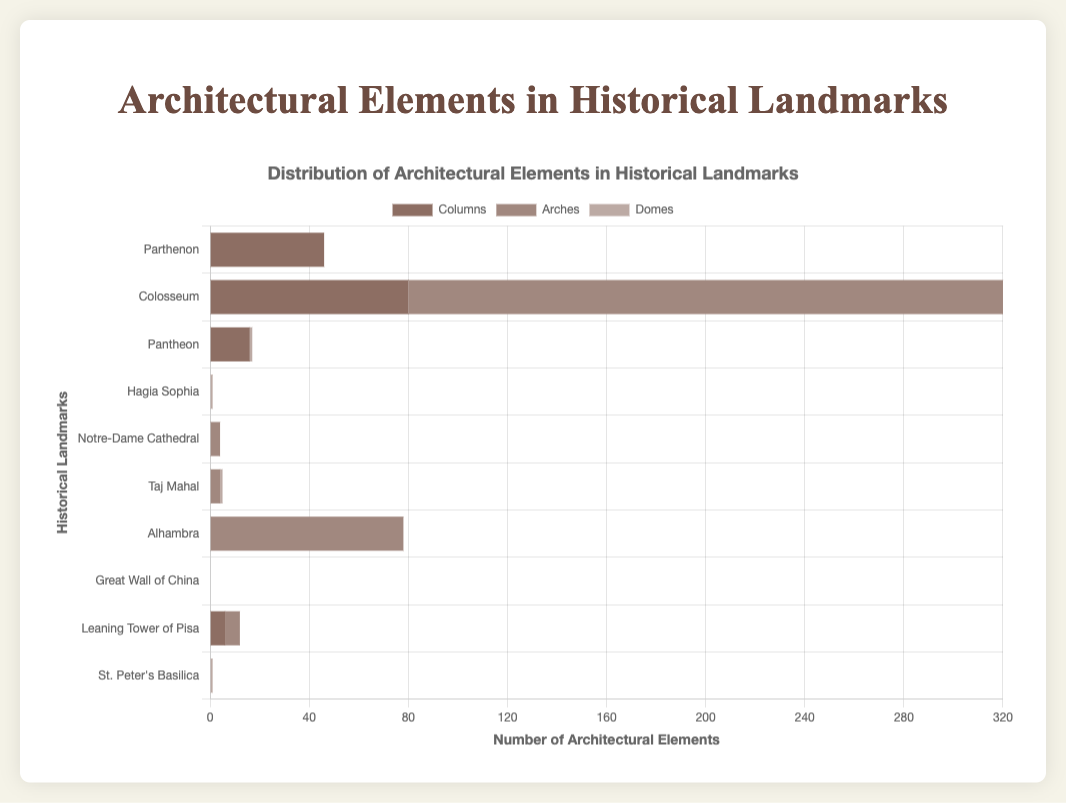Which landmark has the highest number of arches? By observing the bar lengths for arches, the Colosseum has the longest bar, indicating it has the highest number of arches, which is 240.
Answer: Colosseum How many total columns are present in the Parthenon and the Leaning Tower of Pisa combined? To find the total, add the number of columns in the Parthenon (46) to those in the Leaning Tower of Pisa (6). Therefore, 46 + 6 = 52.
Answer: 52 Which architectural element is most frequently found in the Taj Mahal? By comparing the bar lengths for the Taj Mahal, the arches and domes each have bars, but the counts are both 1. Hence, arches and domes are equally frequent.
Answer: Arches and Domes How many landmarks have domes? Observe and count the bars representing domes, which are present for the Pantheon, Hagia Sophia, Taj Mahal, and St. Peter's Basilica. There are 4 such landmarks.
Answer: 4 Is the number of columns in the Colosseum greater than the total number of domes in all landmarks combined? The Colosseum has 80 columns. Sum the domes in all landmarks: 1 (Pantheon) + 1 (Hagia Sophia) + 1 (Taj Mahal) + 1 (St. Peter's Basilica) = 4. Since 80 is greater than 4, the number of columns in the Colosseum is indeed greater.
Answer: Yes What is the average number of arches in landmarks that have arches? The landmarks with arches and their counts are Colosseum (240), Notre-Dame Cathedral (4), Taj Mahal (4), Alhambra (78), and Leaning Tower of Pisa (6). The total is 240 + 4 + 4 + 78 + 6 = 332. The number of landmarks is 5, so the average is 332/5 = 66.4.
Answer: 66.4 Which landmark has the highest total count of architectural elements (columns, arches, and domes combined)? Sum the counts for each landmark: Parthenon (46), Colosseum (320), Pantheon (17), Hagia Sophia (1), Notre-Dame Cathedral (4), Taj Mahal (5), Alhambra (78), Great Wall of China (0), Leaning Tower of Pisa (12), and St. Peter's Basilica (1). The highest total is for the Colosseum with 320 elements.
Answer: Colosseum Do any landmarks feature all three architectural elements (columns, arches, and domes)? Check each landmark for the presence of all three elements. None of the landmarks have all three bars present (columns, arches, and domes).
Answer: No 